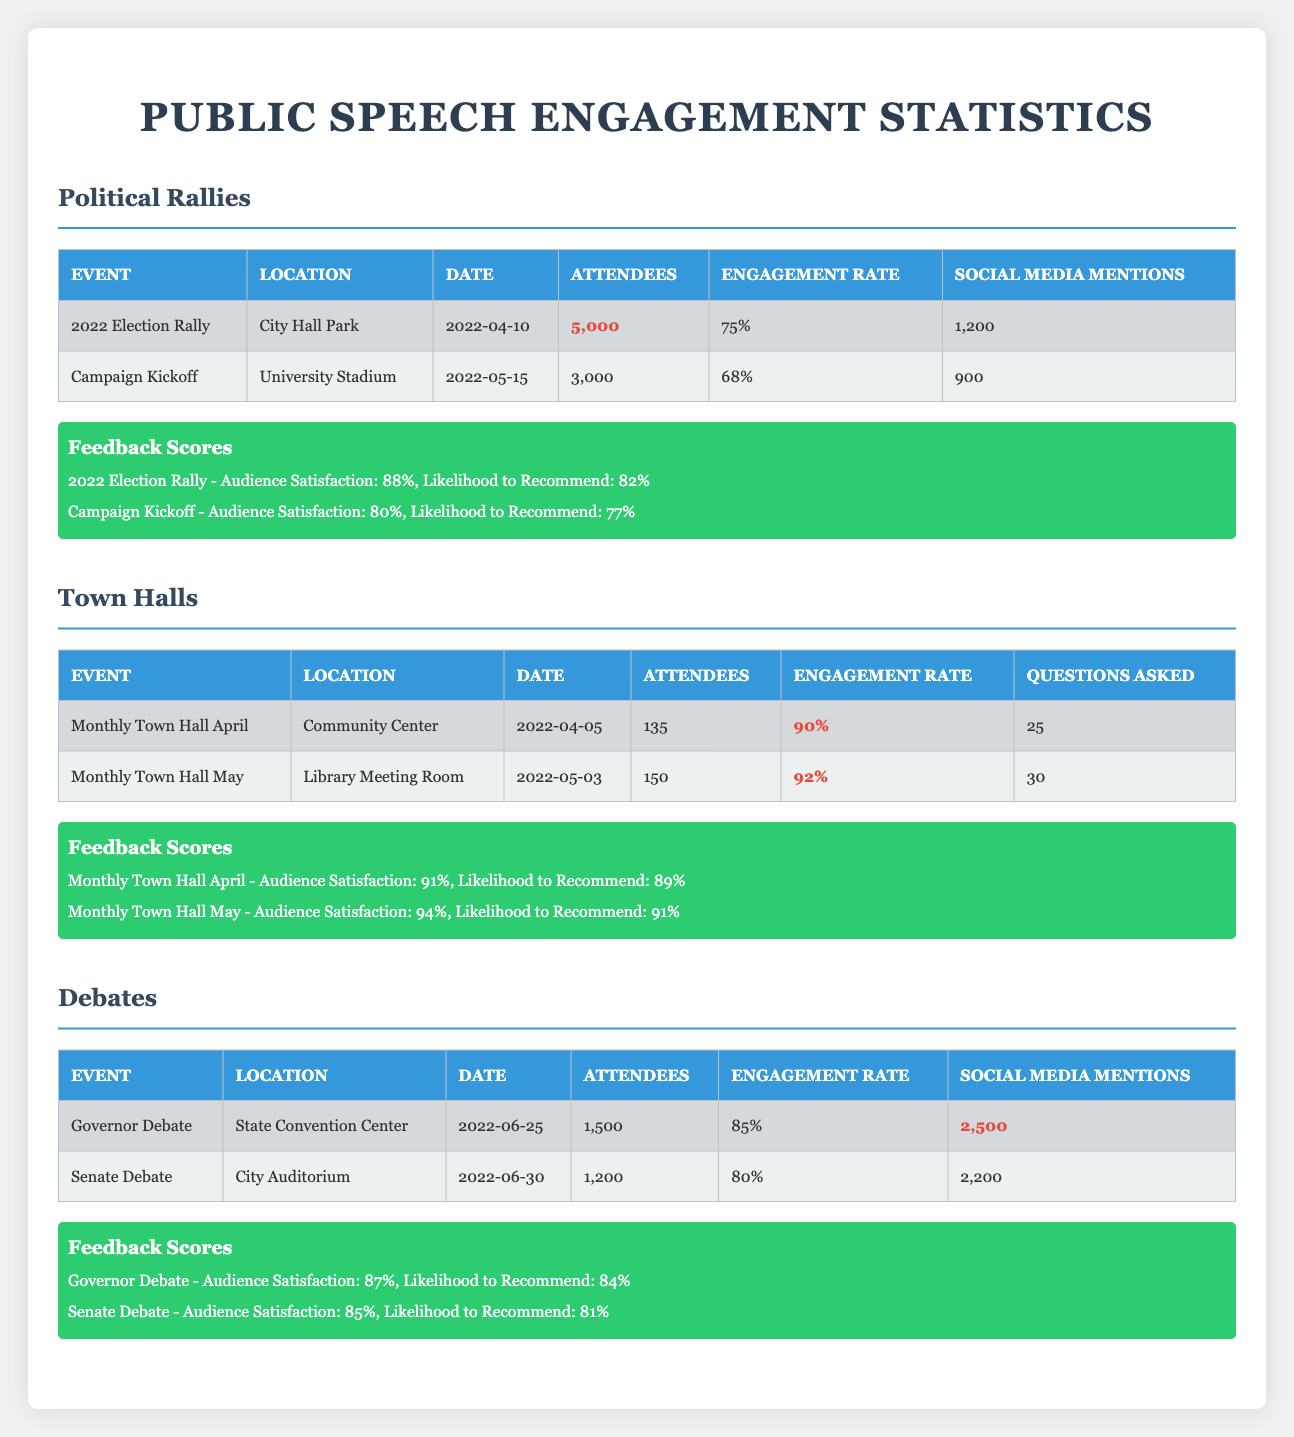What was the highest engagement rate recorded at an event? By looking at the engagement rates provided for each event, the highest engagement rate is found in the Monthly Town Hall in May, which has a rate of 92%.
Answer: 92% How many attendees were present at the 2022 Election Rally? The 2022 Election Rally had 5000 attendees, as noted in the corresponding row of the table.
Answer: 5000 Did the Governor Debate receive more social media mentions than the Senate Debate? The Governor Debate had 2500 social media mentions, while the Senate Debate had 2200. Since 2500 is greater than 2200, the answer is yes.
Answer: Yes What is the average audience satisfaction score for all the events listed? The audience satisfaction scores for the events are 88, 80, 91, 94, 87, and 85. We sum these scores: 88 + 80 + 91 + 94 + 87 + 85 = 525. There are 6 events, so the average audience satisfaction is 525 / 6 = 87.5.
Answer: 87.5 Which town hall event had the highest likelihood to recommend score? The Monthly Town Hall in May had a likelihood to recommend score of 91%, which is higher than April's score of 89%. Thus, May's Town Hall had the highest score.
Answer: 91 